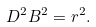<formula> <loc_0><loc_0><loc_500><loc_500>D ^ { 2 } B ^ { 2 } = r ^ { 2 } .</formula> 